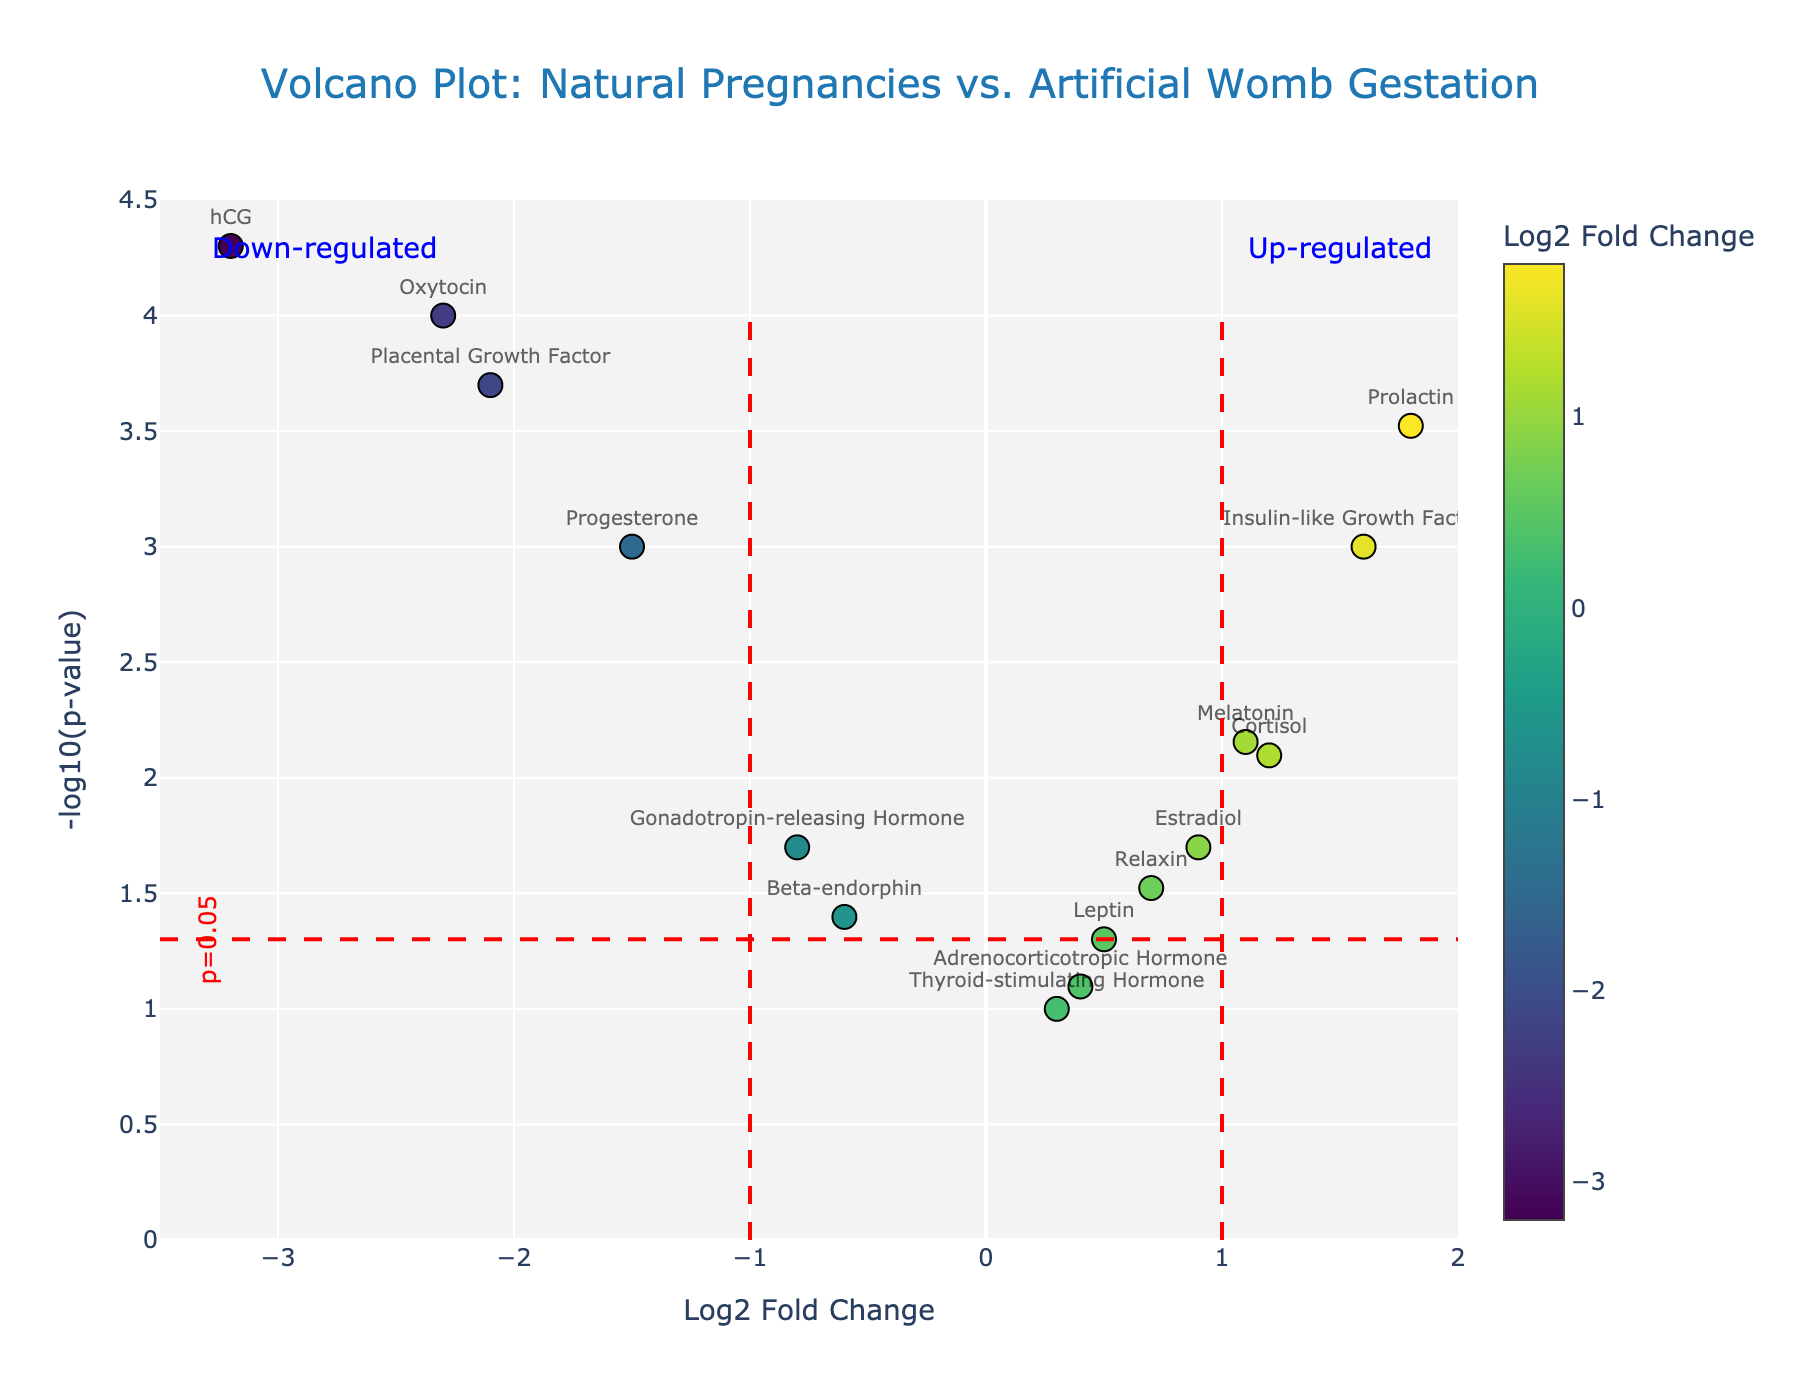What's the title of the plot? The title of the plot is at the top, and it reads "Volcano Plot: Natural Pregnancies vs. Artificial Womb Gestation".
Answer: Volcano Plot: Natural Pregnancies vs. Artificial Womb Gestation What are the axes labels? The x-axis is labeled "Log2 Fold Change", and the y-axis is labeled "-log10(p-value)". These labels are located on the bottom and left sides of the plot, respectively.
Answer: x-axis: Log2 Fold Change, y-axis: -log10(p-value) How many data points are present in the plot? Each gene corresponds to one data point on the plot, marked with a dot and a label. Counting these, there are 15 data points.
Answer: 15 Which gene shows the most significant down-regulation? The most significant down-regulation is indicated by the data point with the largest negative Log2 Fold Change and the smallest p-value. The gene hCG has the smallest p-value and a Log2 Fold Change of -3.2.
Answer: hCG Which gene appears just below the p = 0.05 threshold line and is down-regulated? To find this gene, we look for a data point just below the horizontal red dashed line (representing p = 0.05) with a Log2 Fold Change less than 0. Gonadotropin-releasing Hormone fits this criterion.
Answer: Gonadotropin-releasing Hormone Which gene is both significantly up-regulated and has one of the highest Log2 Fold Changes? We look for an up-regulated gene (positive Log2 Fold Change) with a low p-value. Prolactin has one of the highest Log2 Fold Changes at 1.8 and a p-value of 0.0003.
Answer: Prolactin How many genes are significantly up-regulated? Genes that are significantly up-regulated have positive Log2 Fold Changes and are above the p = 0.05 threshold line. The genes Prolactin, Insulin-like Growth Factor 1, Cortisol, and Melatonin fit this criterion.
Answer: 4 Which gene has the smallest p-value? The smallest p-value is visually indicated by the highest up-pointing data point. The gene hCG, with a p-value of 0.00005, has the smallest p-value.
Answer: hCG What is the Log2 Fold Change for Oxytocin, and is it significant? Oxytocin is labeled on the plot at a point with a Log2 Fold Change of -2.3. It is above the p = 0.05 threshold line, making it significant.
Answer: -2.3, yes 